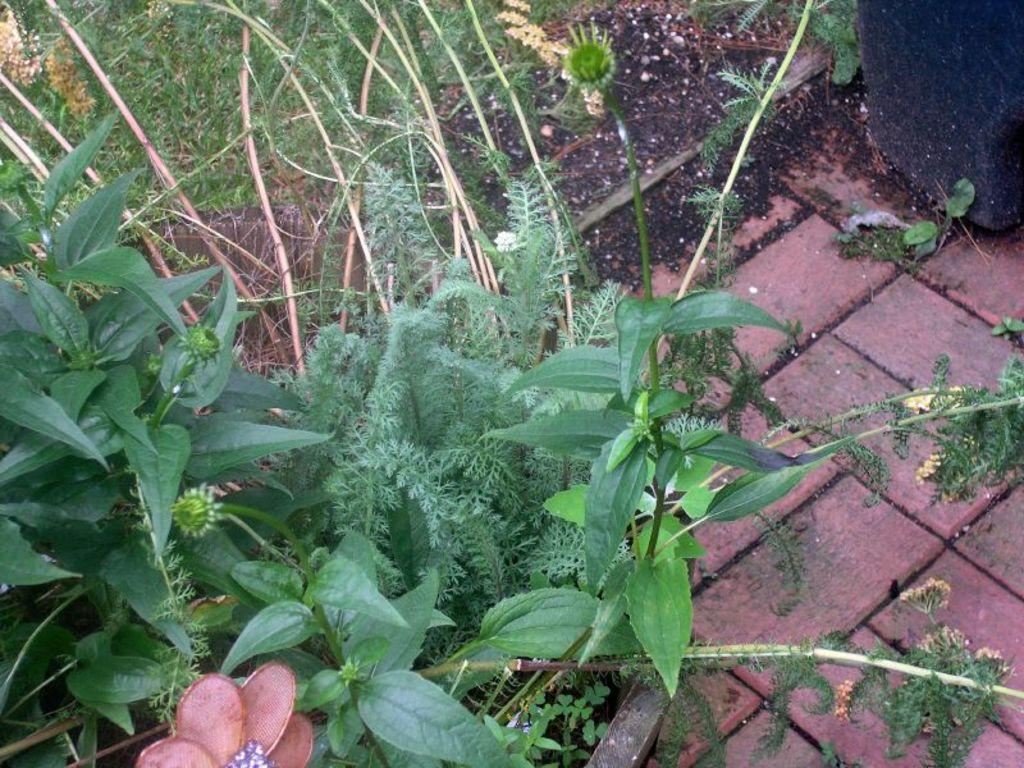What type of vegetation can be seen in the image? There are plants in the image. What type of ground cover is visible in the image? The grass is visible in the image. What else can be found on the ground in the image? There are other objects on the ground in the image. What type of salt is being used to season the meal in the image? There is no meal or salt present in the image; it features plants and grass. What type of relation can be seen between the plants in the image? There is no indication of a relation between the plants in the image; they are simply depicted as individual plants. 